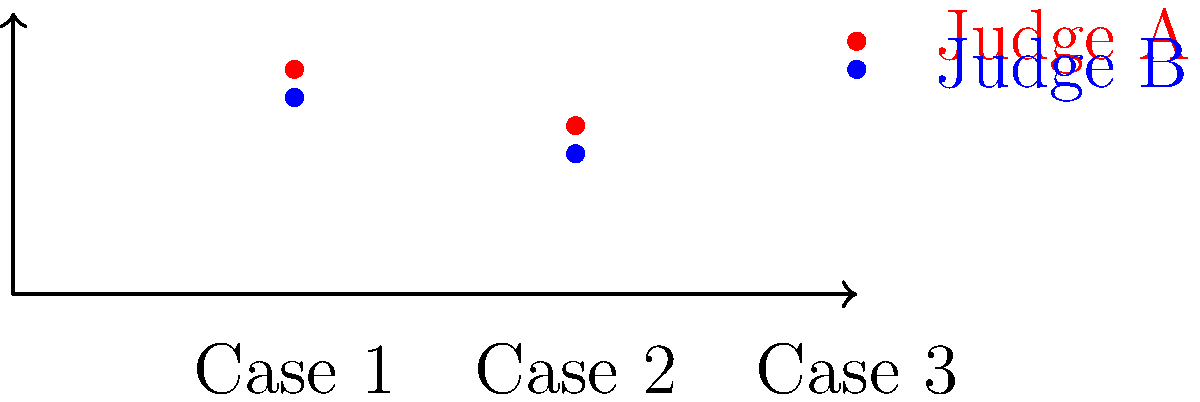Given the voting patterns of two judges (A and B) across three cases as shown in the graph, where each point represents the likelihood of a favorable decision, calculate the cosine similarity between their voting patterns. How would you interpret this result in the context of judicial decision-making? To solve this problem, we'll follow these steps:

1) First, we need to identify the vectors representing each judge's voting pattern:
   Judge A: $\vec{a} = [0.8, 0.6, 0.9]$
   Judge B: $\vec{b} = [0.7, 0.5, 0.8]$

2) The cosine similarity is calculated using the formula:
   $$\text{cosine similarity} = \frac{\vec{a} \cdot \vec{b}}{|\vec{a}| |\vec{b}|}$$

3) Calculate the dot product $\vec{a} \cdot \vec{b}$:
   $$(0.8 * 0.7) + (0.6 * 0.5) + (0.9 * 0.8) = 0.56 + 0.3 + 0.72 = 1.58$$

4) Calculate $|\vec{a}|$:
   $$\sqrt{0.8^2 + 0.6^2 + 0.9^2} = \sqrt{0.64 + 0.36 + 0.81} = \sqrt{1.81} \approx 1.3454$$

5) Calculate $|\vec{b}|$:
   $$\sqrt{0.7^2 + 0.5^2 + 0.8^2} = \sqrt{0.49 + 0.25 + 0.64} = \sqrt{1.38} \approx 1.1747$$

6) Now, we can calculate the cosine similarity:
   $$\frac{1.58}{1.3454 * 1.1747} \approx 0.9978$$

7) Interpretation: The cosine similarity is very close to 1, indicating that the voting patterns of Judge A and Judge B are highly similar. This suggests that these judges tend to vote in a very similar manner across the three cases, despite small differences in their exact voting likelihoods.
Answer: Cosine similarity ≈ 0.9978. High similarity in voting patterns, suggesting consistent agreement between judges. 